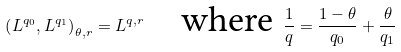<formula> <loc_0><loc_0><loc_500><loc_500>\left ( L ^ { q _ { 0 } } , L ^ { q _ { 1 } } \right ) _ { \theta , r } = L ^ { q , r } \quad \text {where } \frac { 1 } q = \frac { 1 - \theta } { q _ { 0 } } + \frac { \theta } { q _ { 1 } }</formula> 